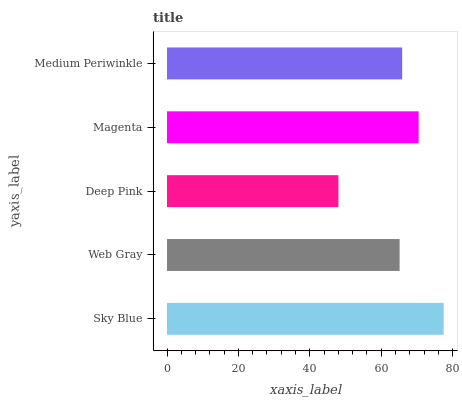Is Deep Pink the minimum?
Answer yes or no. Yes. Is Sky Blue the maximum?
Answer yes or no. Yes. Is Web Gray the minimum?
Answer yes or no. No. Is Web Gray the maximum?
Answer yes or no. No. Is Sky Blue greater than Web Gray?
Answer yes or no. Yes. Is Web Gray less than Sky Blue?
Answer yes or no. Yes. Is Web Gray greater than Sky Blue?
Answer yes or no. No. Is Sky Blue less than Web Gray?
Answer yes or no. No. Is Medium Periwinkle the high median?
Answer yes or no. Yes. Is Medium Periwinkle the low median?
Answer yes or no. Yes. Is Deep Pink the high median?
Answer yes or no. No. Is Web Gray the low median?
Answer yes or no. No. 